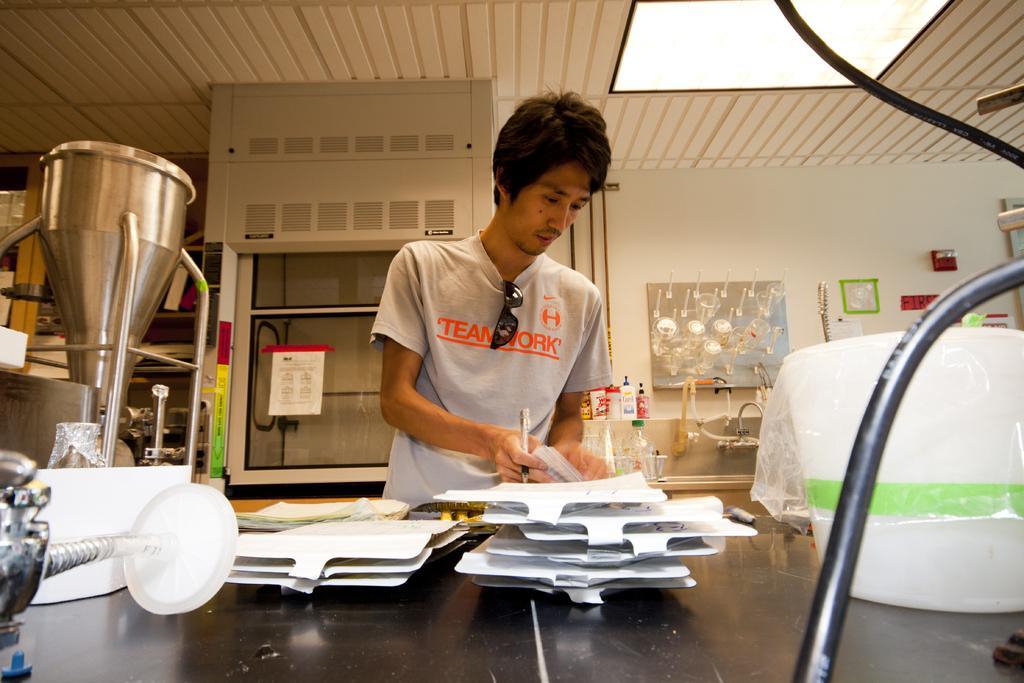Can you describe this image briefly? In the image,there is a man standing in front of the table and on the table there are many papers and books and some objects are kept. Behind the man there is a wash basin and beside that there are some lotions and hand wash are placed on the shelf and in the background there is a wall and to the roof there is a light. 